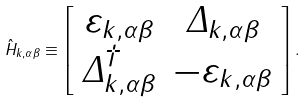Convert formula to latex. <formula><loc_0><loc_0><loc_500><loc_500>\hat { H } _ { { k } , \alpha \beta } \equiv \left [ \begin{array} { c c } \varepsilon _ { { k } , \alpha \beta } & \mathit \Delta _ { { k } , \alpha \beta } \\ \mathit \Delta _ { { k } , \alpha \beta } ^ { \dagger } & - \varepsilon _ { { k } , \alpha \beta } \end{array} \right ] .</formula> 